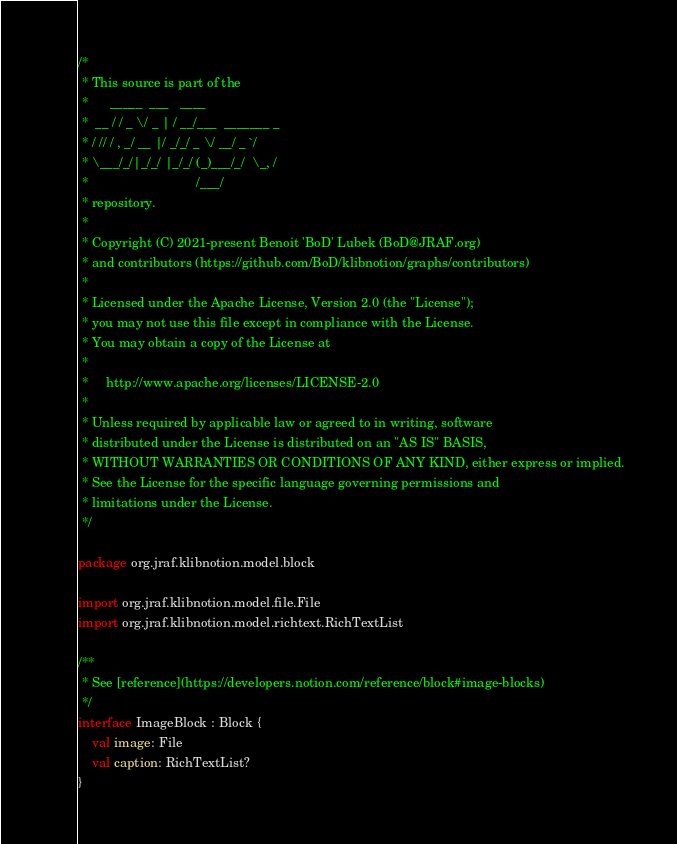Convert code to text. <code><loc_0><loc_0><loc_500><loc_500><_Kotlin_>/*
 * This source is part of the
 *      _____  ___   ____
 *  __ / / _ \/ _ | / __/___  _______ _
 * / // / , _/ __ |/ _/_/ _ \/ __/ _ `/
 * \___/_/|_/_/ |_/_/ (_)___/_/  \_, /
 *                              /___/
 * repository.
 *
 * Copyright (C) 2021-present Benoit 'BoD' Lubek (BoD@JRAF.org)
 * and contributors (https://github.com/BoD/klibnotion/graphs/contributors)
 *
 * Licensed under the Apache License, Version 2.0 (the "License");
 * you may not use this file except in compliance with the License.
 * You may obtain a copy of the License at
 *
 *     http://www.apache.org/licenses/LICENSE-2.0
 *
 * Unless required by applicable law or agreed to in writing, software
 * distributed under the License is distributed on an "AS IS" BASIS,
 * WITHOUT WARRANTIES OR CONDITIONS OF ANY KIND, either express or implied.
 * See the License for the specific language governing permissions and
 * limitations under the License.
 */

package org.jraf.klibnotion.model.block

import org.jraf.klibnotion.model.file.File
import org.jraf.klibnotion.model.richtext.RichTextList

/**
 * See [reference](https://developers.notion.com/reference/block#image-blocks)
 */
interface ImageBlock : Block {
    val image: File
    val caption: RichTextList?
}
</code> 